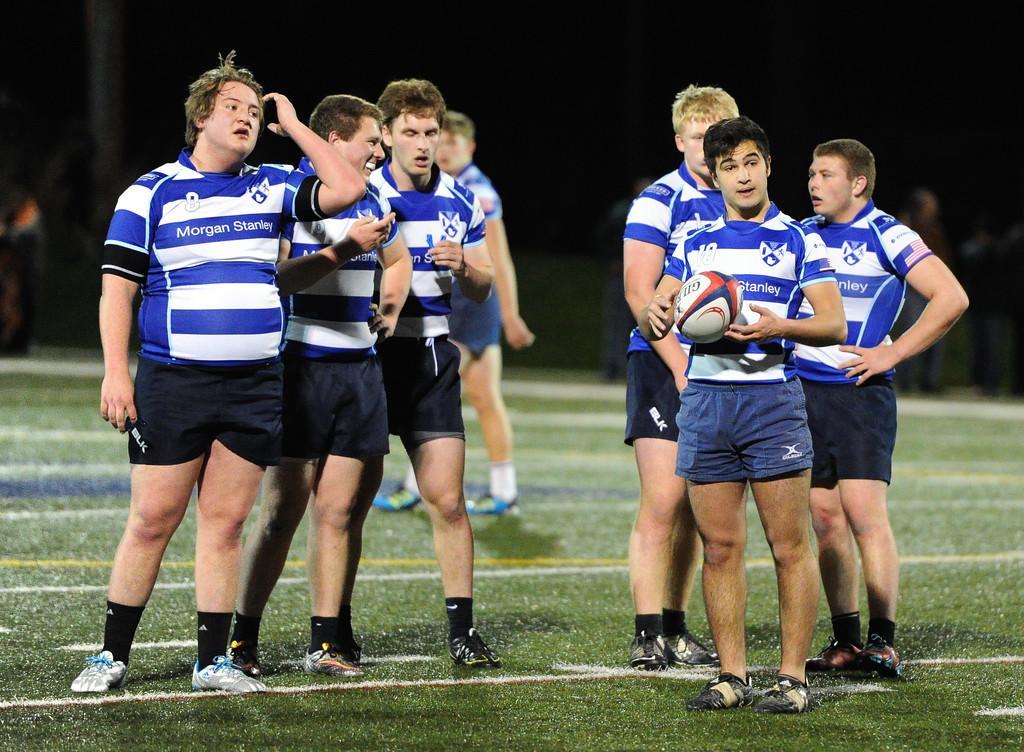Could you give a brief overview of what you see in this image? In this image there are people. There is grass. There is a dark background. Some people are standing on the backside I think. 